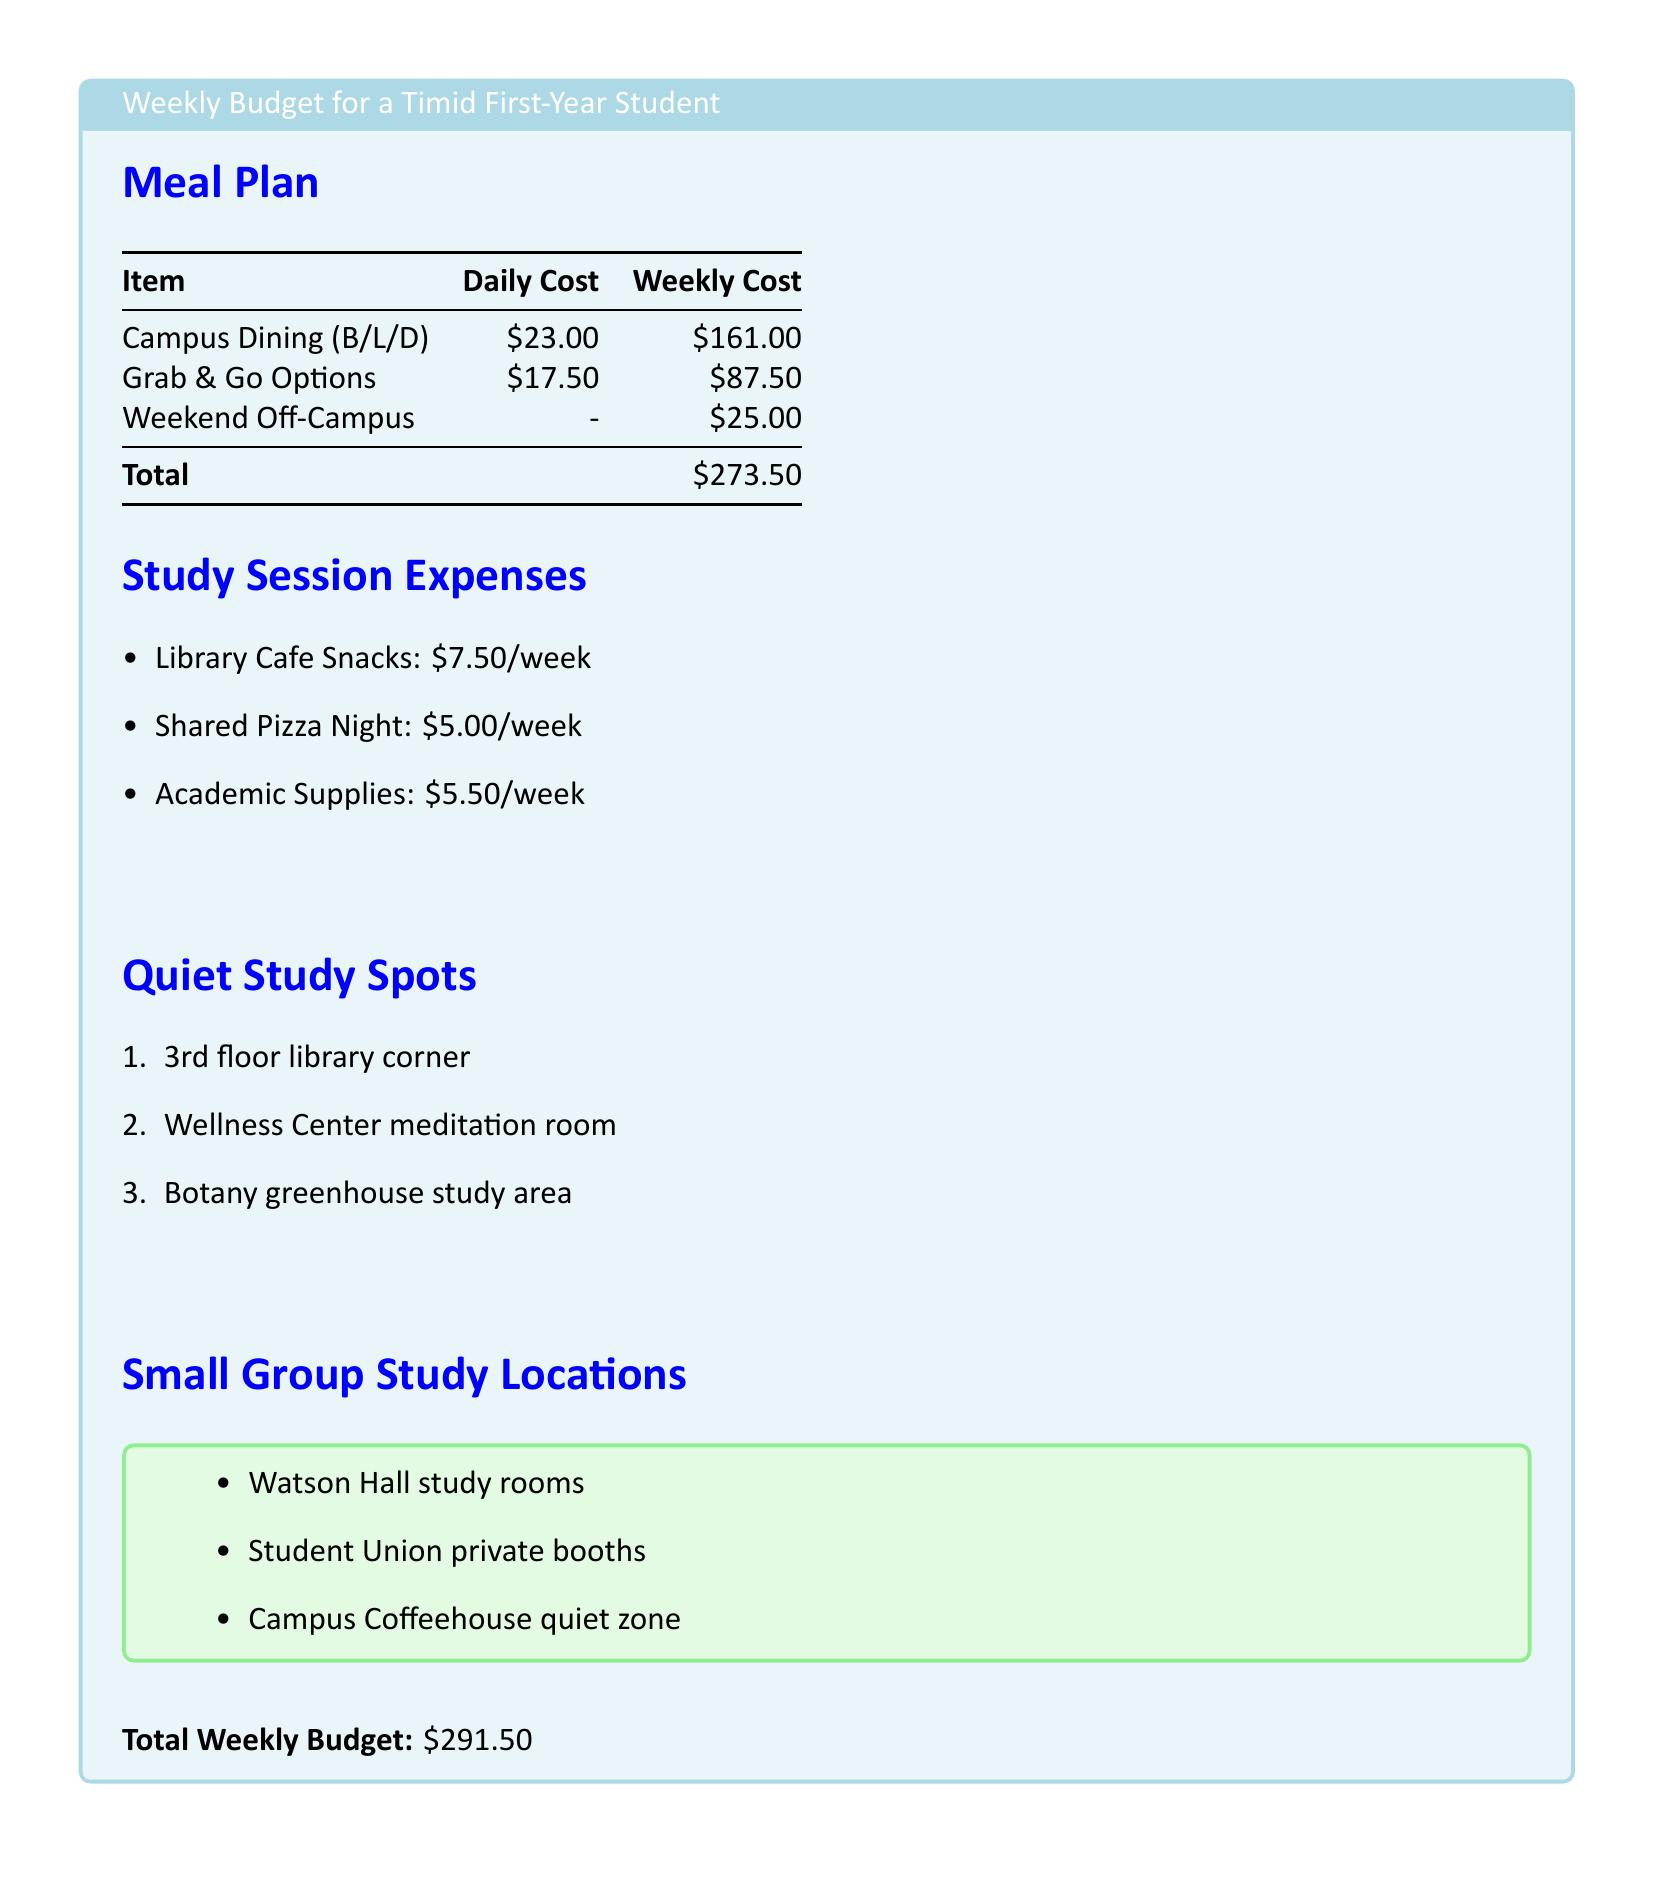What is the weekly cost of Campus Dining? The document lists the weekly cost of Campus Dining as $161.00.
Answer: $161.00 What is the total weekly budget? The total weekly budget sums up all meal and study session expenses, which is $291.50.
Answer: $291.50 How much does Grab & Go Options cost per day? Grab & Go Options is listed as costing $17.50 per day in the document.
Answer: $17.50 Where is one quiet study spot mentioned? The document lists several quiet study spots, one being the Wellness Center meditation room.
Answer: Wellness Center meditation room What are the total costs for snacks from the Library Cafe? The document states the cost for Library Cafe Snacks is $7.50 per week.
Answer: $7.50 How much does Shared Pizza Night cost? Shared Pizza Night is detailed in the document as costing $5.00 per week.
Answer: $5.00 What is the cost for Academic Supplies per week? The document indicates that Academic Supplies cost $5.50 per week.
Answer: $5.50 Which floor of the library is mentioned as a quiet study spot? The document mentions the 3rd floor library corner as a quiet study spot.
Answer: 3rd floor library corner What is one listed location for small group study? The document lists Watson Hall study rooms as one location for small group study.
Answer: Watson Hall study rooms 